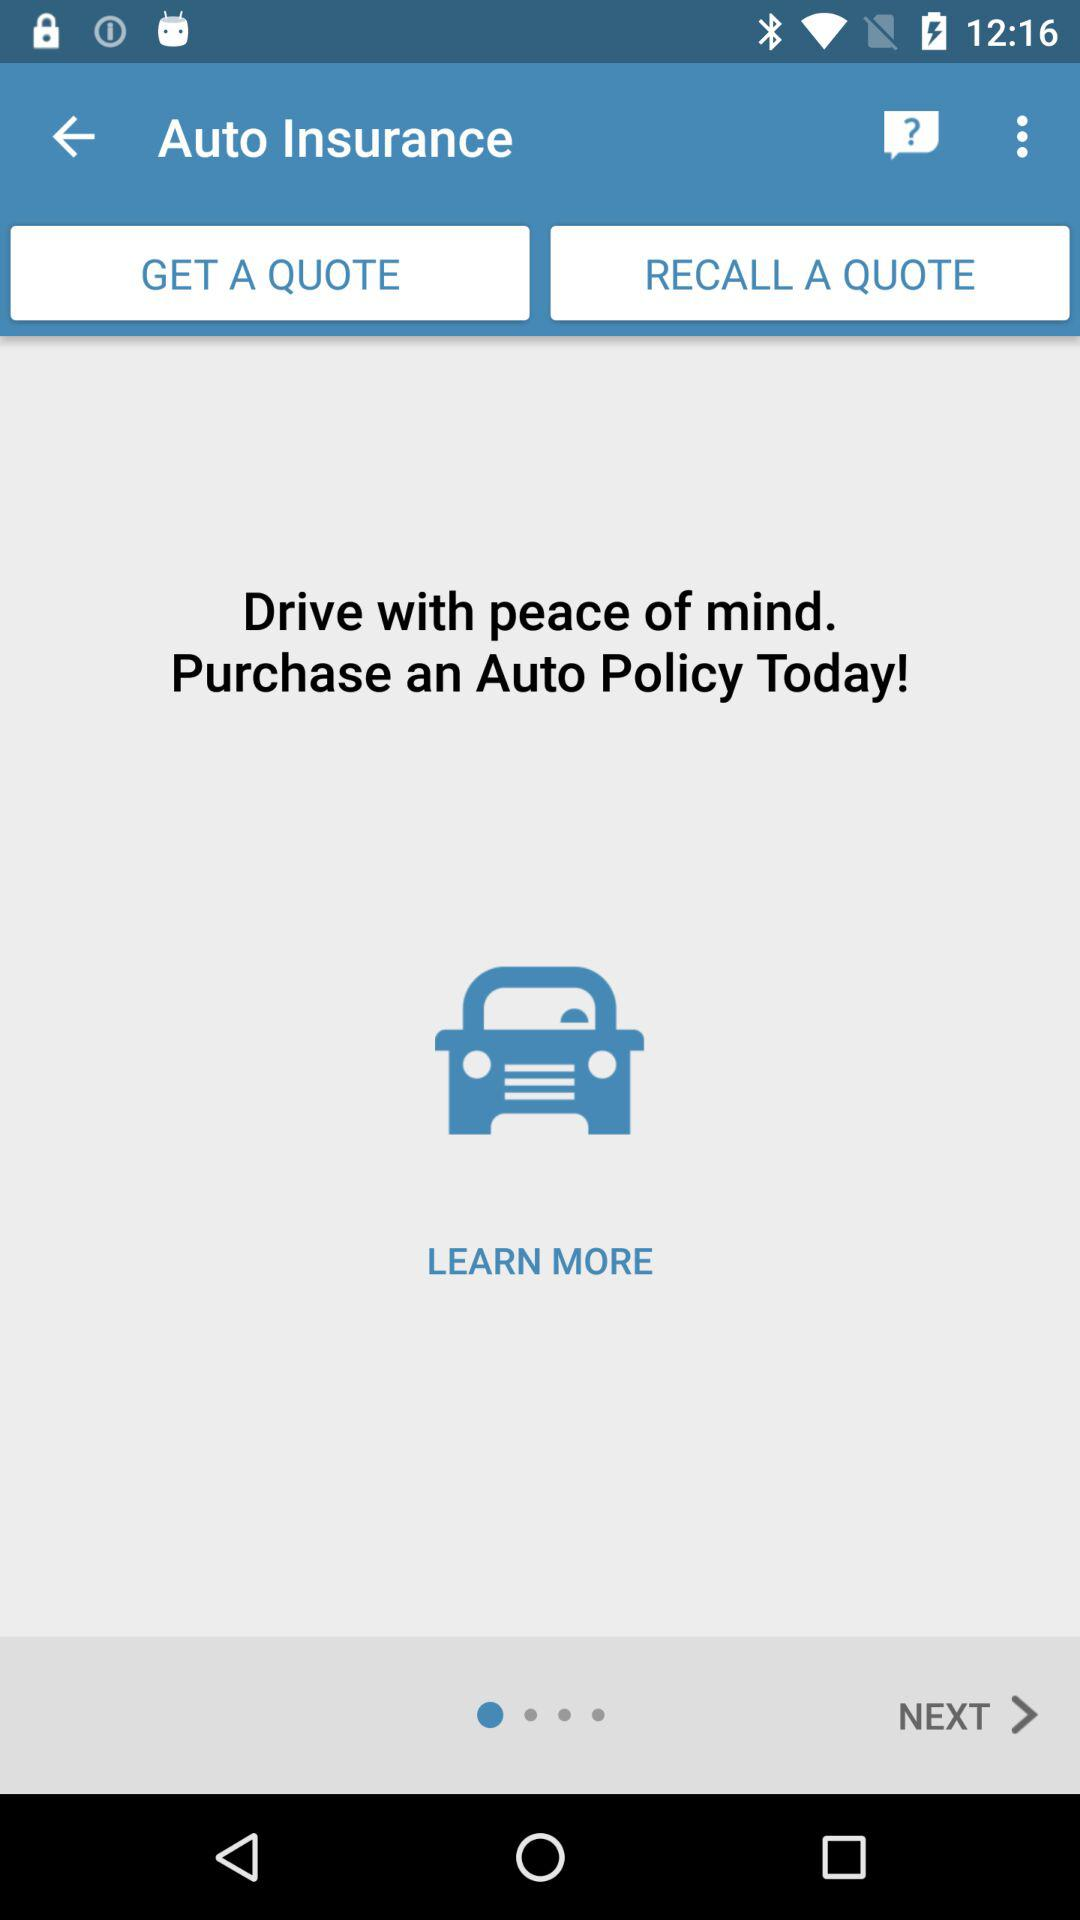What do we need to purchase to drive with peace of mind? You need to purchase an auto policy to drive with peace of mind. 